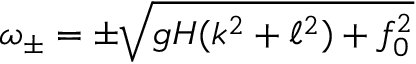Convert formula to latex. <formula><loc_0><loc_0><loc_500><loc_500>\omega _ { \pm } = \pm \sqrt { g H ( k ^ { 2 } + \ell ^ { 2 } ) + f _ { 0 } ^ { 2 } }</formula> 